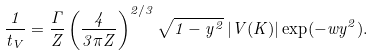Convert formula to latex. <formula><loc_0><loc_0><loc_500><loc_500>\frac { 1 } { t _ { V } } = \frac { \Gamma } { Z } \left ( \frac { 4 } { 3 \pi Z } \right ) ^ { 2 / 3 } \sqrt { 1 - y ^ { 2 } } \, | V ( K ) | \exp ( - w y ^ { 2 } ) .</formula> 